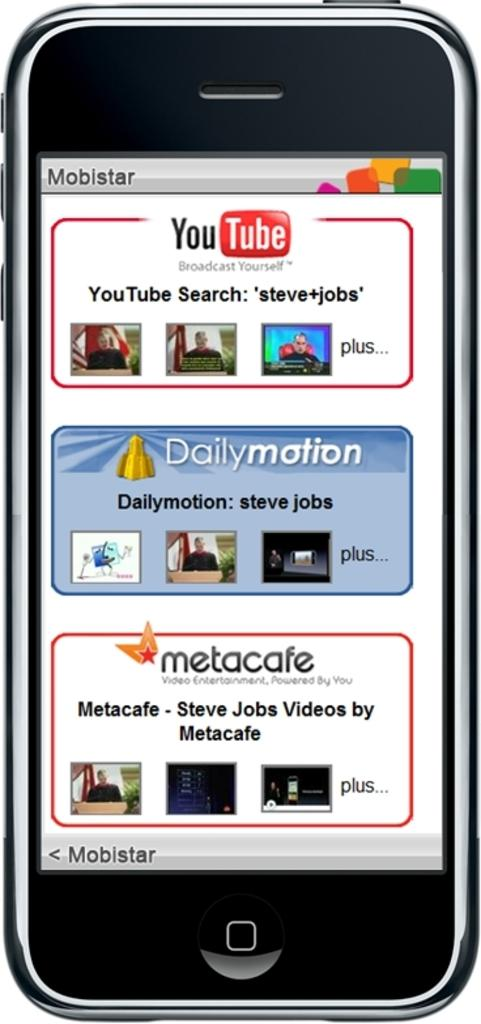<image>
Present a compact description of the photo's key features. A Mobistar cell phone is searching for Steve Jobs on YouTube.. 